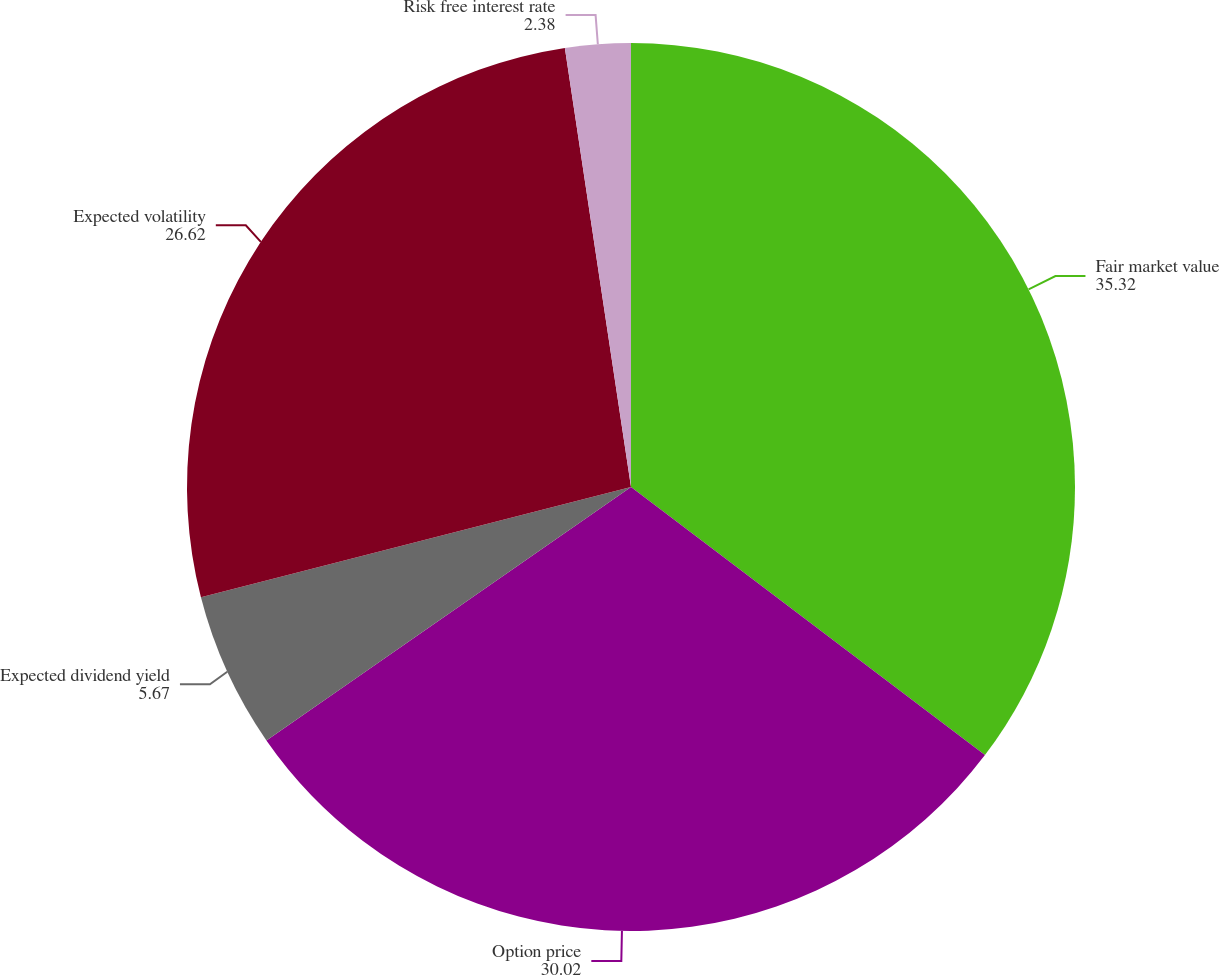<chart> <loc_0><loc_0><loc_500><loc_500><pie_chart><fcel>Fair market value<fcel>Option price<fcel>Expected dividend yield<fcel>Expected volatility<fcel>Risk free interest rate<nl><fcel>35.32%<fcel>30.02%<fcel>5.67%<fcel>26.62%<fcel>2.38%<nl></chart> 